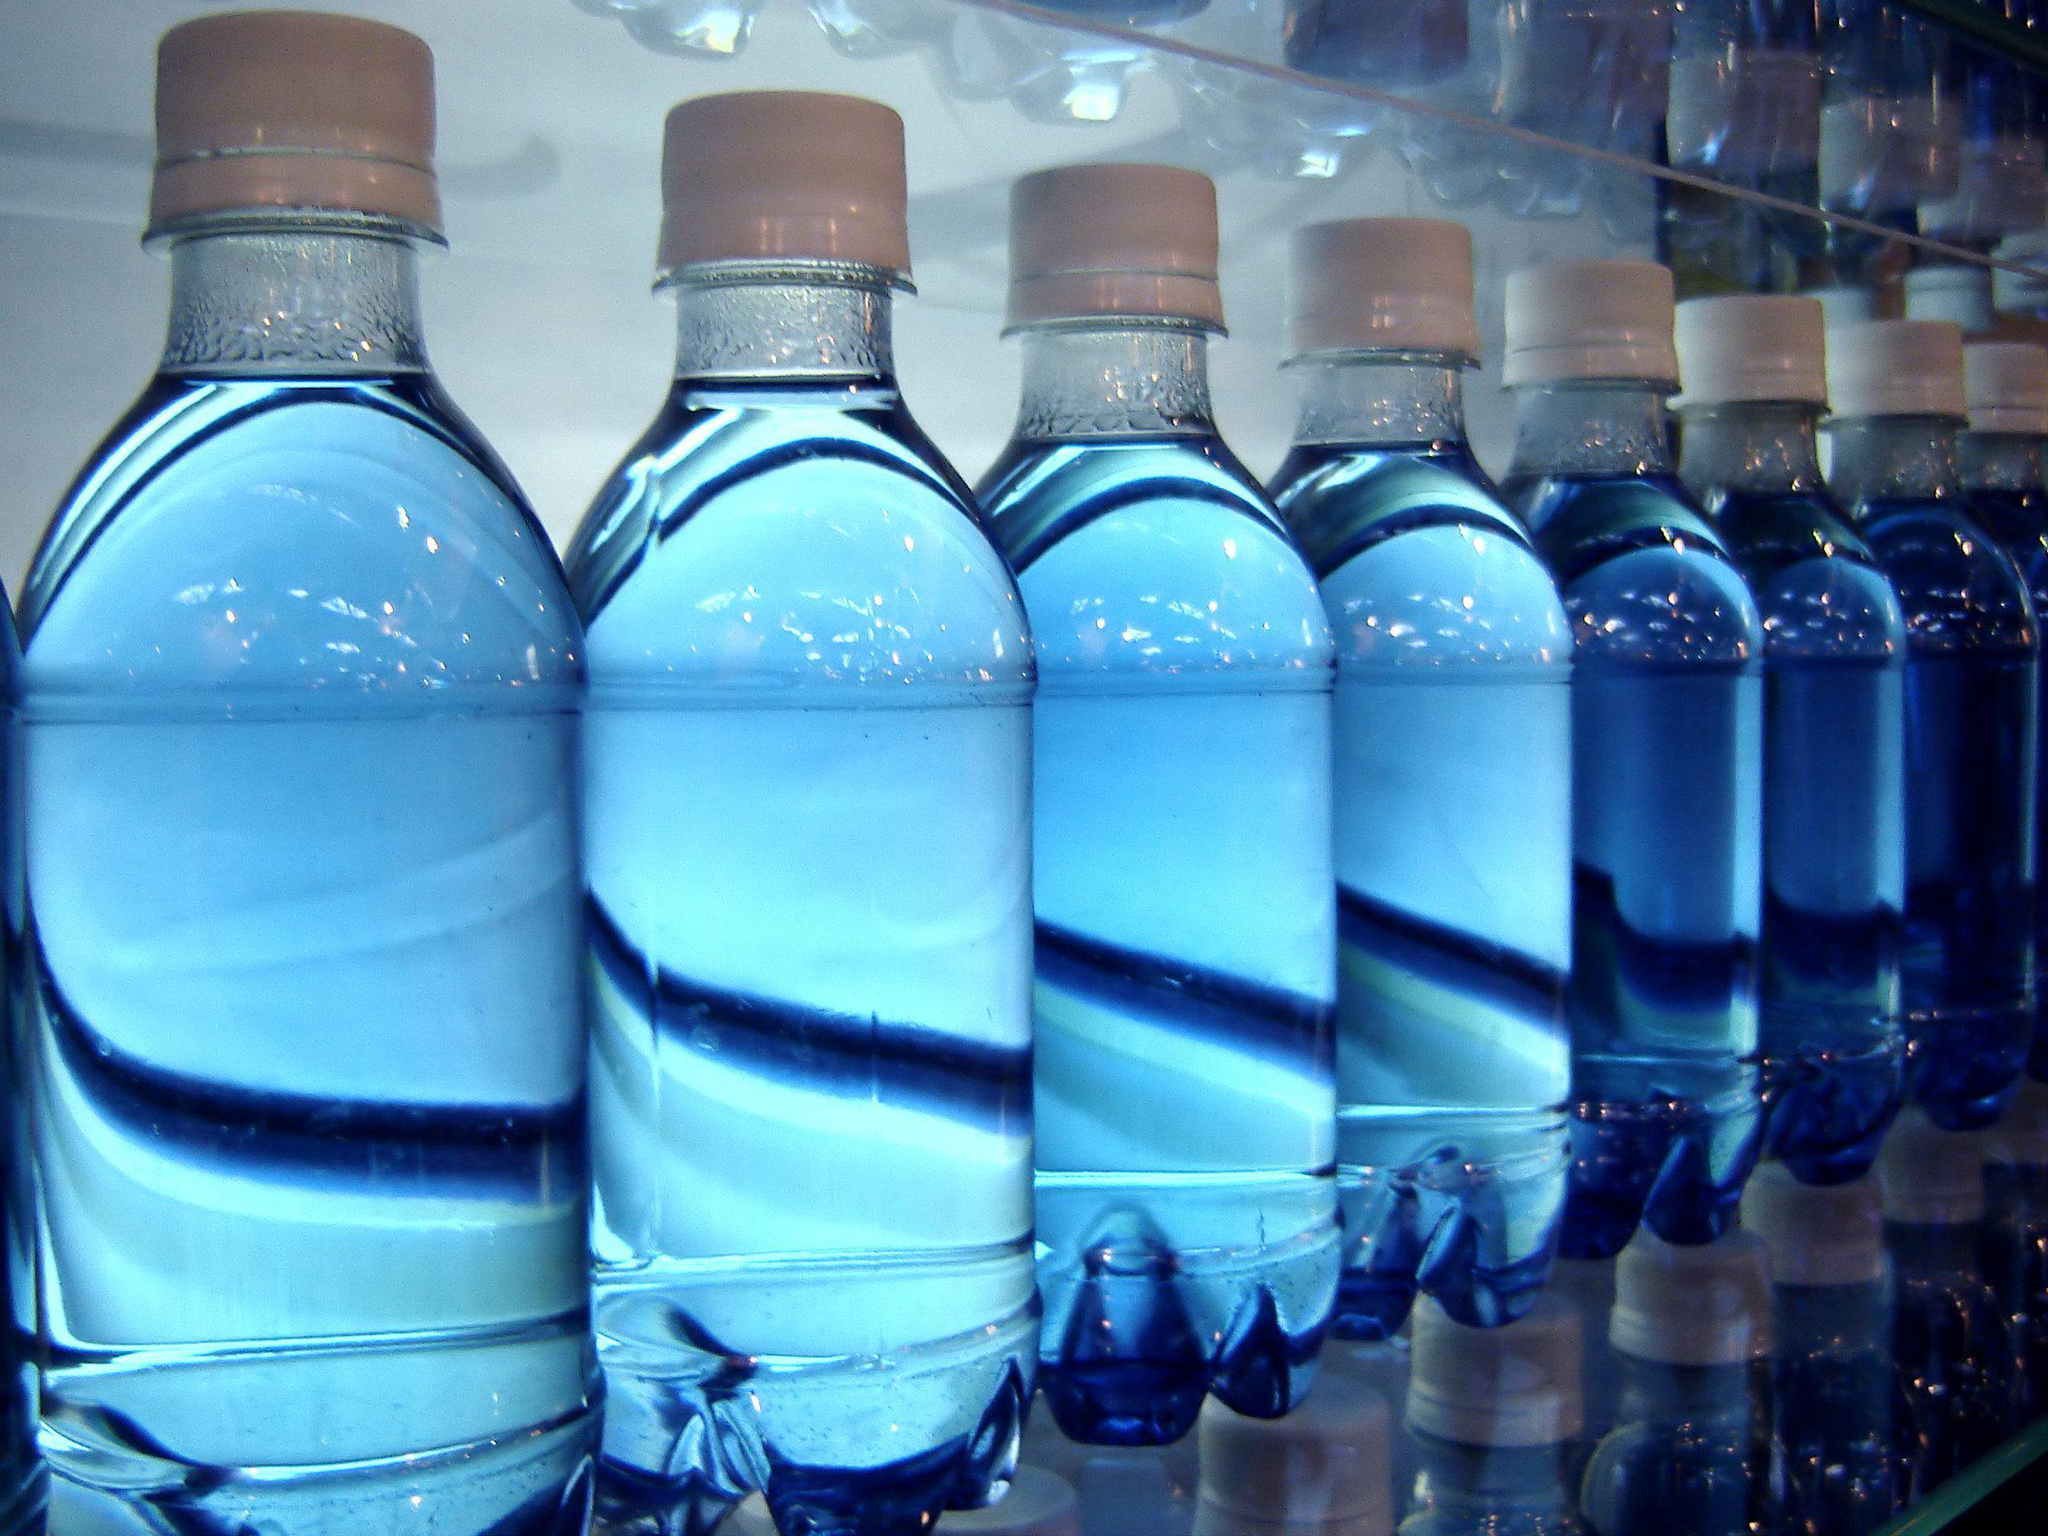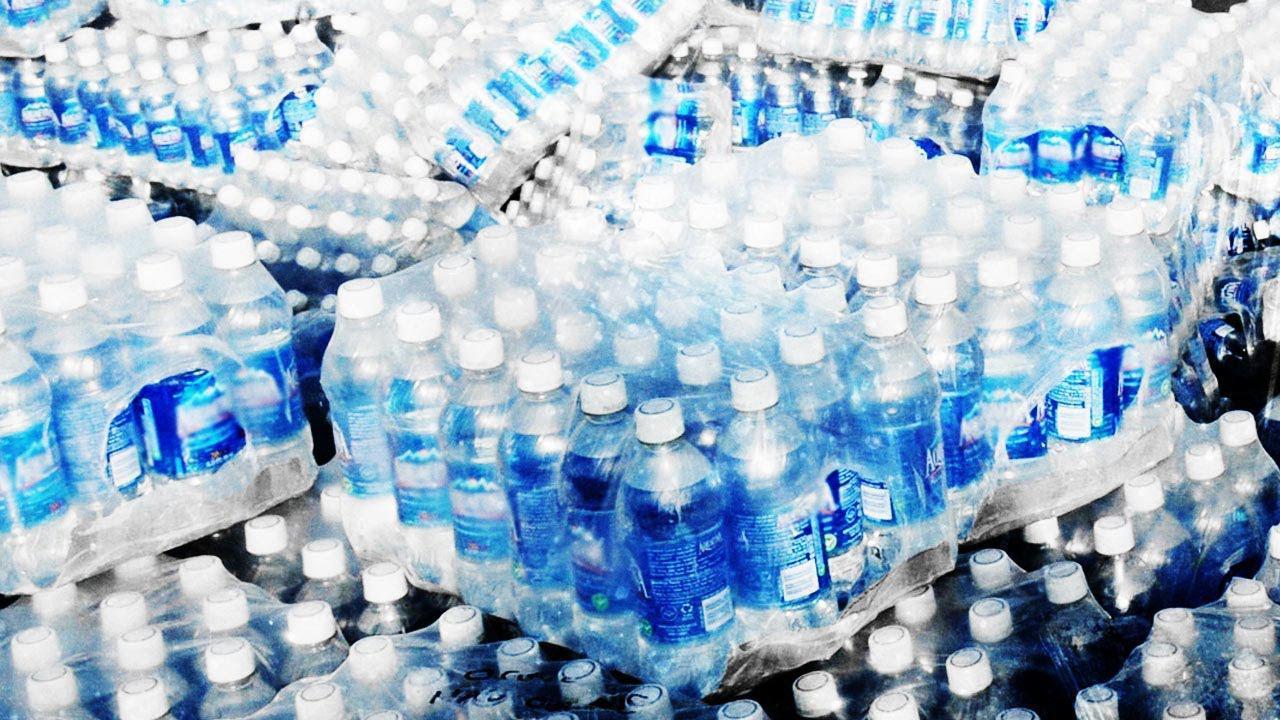The first image is the image on the left, the second image is the image on the right. For the images shown, is this caption "the bottles in the image on the right have white caps." true? Answer yes or no. Yes. The first image is the image on the left, the second image is the image on the right. For the images displayed, is the sentence "The bottles have white caps in at least one of the images." factually correct? Answer yes or no. Yes. 